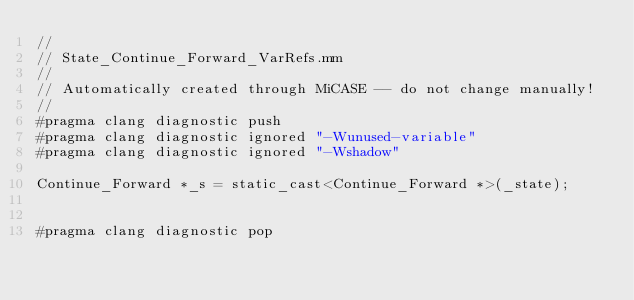Convert code to text. <code><loc_0><loc_0><loc_500><loc_500><_ObjectiveC_>//
// State_Continue_Forward_VarRefs.mm
//
// Automatically created through MiCASE -- do not change manually!
//
#pragma clang diagnostic push
#pragma clang diagnostic ignored "-Wunused-variable"
#pragma clang diagnostic ignored "-Wshadow"

Continue_Forward *_s = static_cast<Continue_Forward *>(_state);


#pragma clang diagnostic pop
</code> 